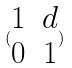<formula> <loc_0><loc_0><loc_500><loc_500>( \begin{matrix} 1 & d \\ 0 & 1 \end{matrix} )</formula> 